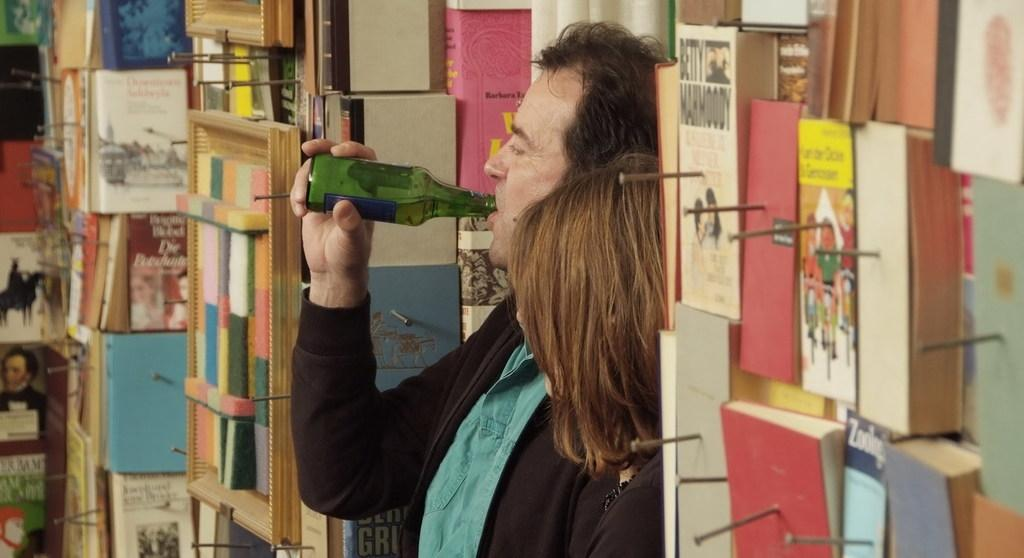How many people are present in the image? There are two people in the image. What is one person holding in the image? One person is holding a bottle. What can be seen besides the people in the image? There are books visible in the image. What is attached to the wall in the image? There are needles attached to the wall in the image. What type of door can be seen in the image? There is no door present in the image. How many thumbs are visible on the people in the image? The number of thumbs cannot be determined from the image, as only the presence of people and a bottle is mentioned. 